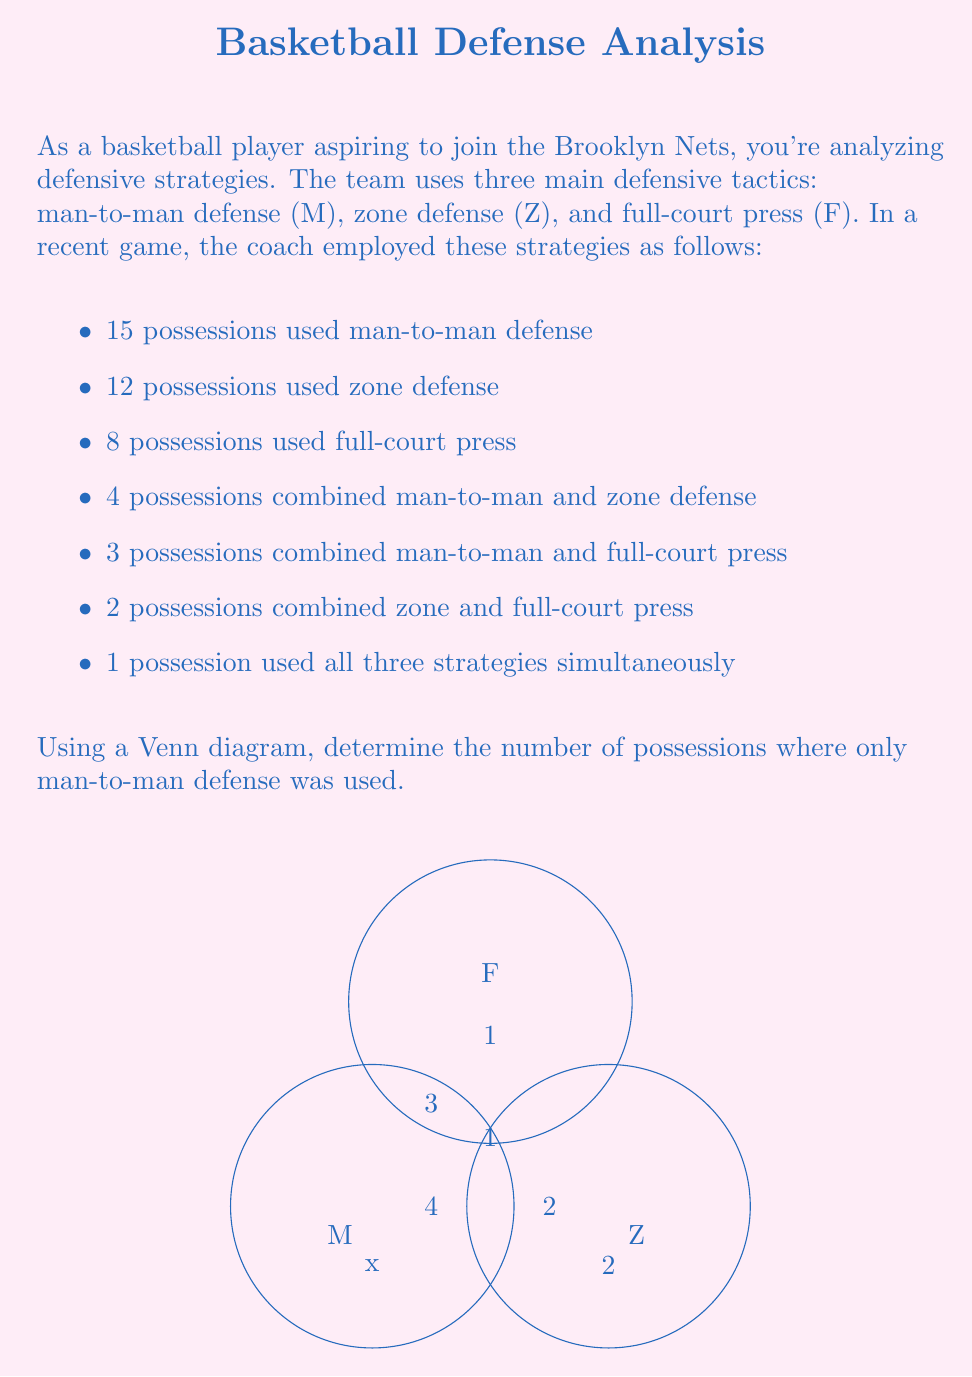Help me with this question. Let's approach this step-by-step using the given information and the Venn diagram:

1) Let $x$ be the number of possessions where only man-to-man defense was used.

2) We can write an equation based on the total number of man-to-man defense possessions:

   $x + 4 + 3 + 1 = 15$

3) Solve for $x$:
   $x = 15 - 4 - 3 - 1 = 7$

To verify, let's check the total number of possessions:

4) Only man-to-man (M): 7
5) Only zone (Z): 2 (given in the diagram)
6) Only full-court press (F): 1 (given in the diagram)
7) M and Z overlap: 4
8) M and F overlap: 3
9) Z and F overlap: 2
10) All three overlap: 1

11) Total: $7 + 2 + 1 + 4 + 3 + 2 + 1 = 20$

This matches the sum of individual strategy uses: $15 + 12 + 8 - 4 - 3 - 2 + 1 = 20$ (subtracting overlaps to avoid double-counting, then adding back the triple overlap)

Therefore, 7 possessions used only man-to-man defense.
Answer: 7 possessions 